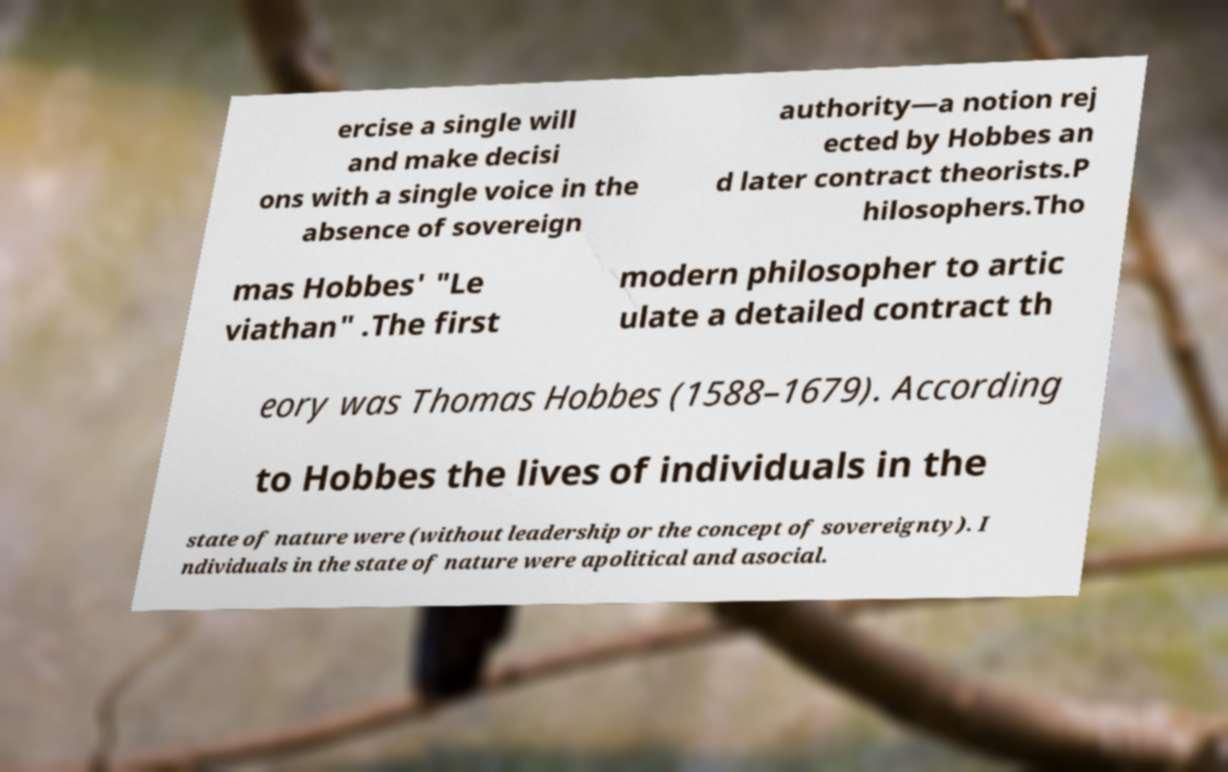Could you extract and type out the text from this image? ercise a single will and make decisi ons with a single voice in the absence of sovereign authority—a notion rej ected by Hobbes an d later contract theorists.P hilosophers.Tho mas Hobbes' "Le viathan" .The first modern philosopher to artic ulate a detailed contract th eory was Thomas Hobbes (1588–1679). According to Hobbes the lives of individuals in the state of nature were (without leadership or the concept of sovereignty). I ndividuals in the state of nature were apolitical and asocial. 